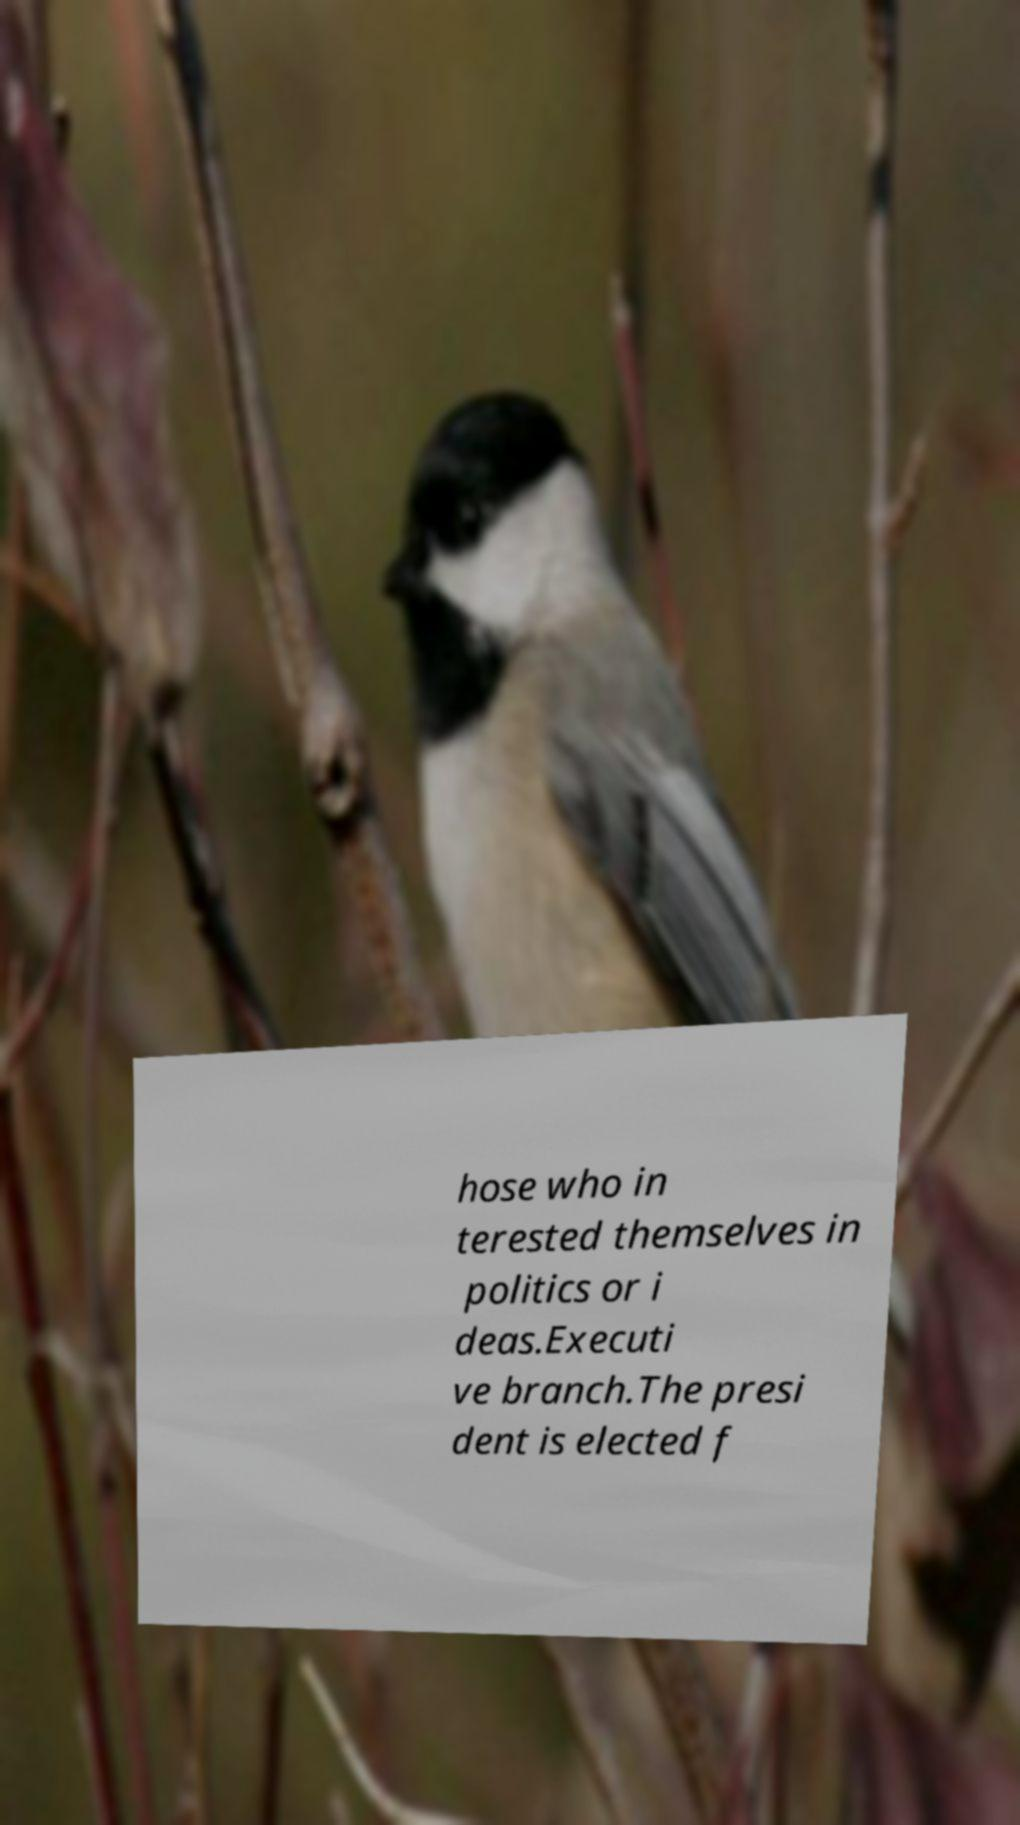Please read and relay the text visible in this image. What does it say? hose who in terested themselves in politics or i deas.Executi ve branch.The presi dent is elected f 